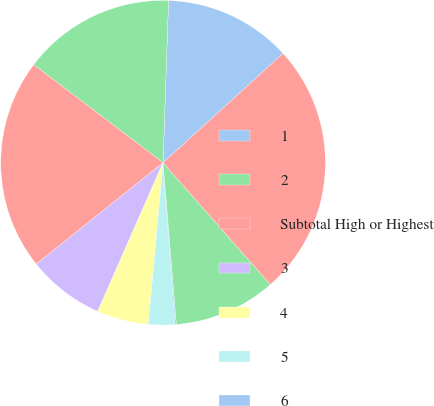Convert chart. <chart><loc_0><loc_0><loc_500><loc_500><pie_chart><fcel>1<fcel>2<fcel>Subtotal High or Highest<fcel>3<fcel>4<fcel>5<fcel>6<fcel>Subtotal Other Securities(4)<fcel>Total Private Fixed Maturities<nl><fcel>12.7%<fcel>15.21%<fcel>21.06%<fcel>7.67%<fcel>5.15%<fcel>2.64%<fcel>0.12%<fcel>10.18%<fcel>25.27%<nl></chart> 